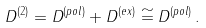<formula> <loc_0><loc_0><loc_500><loc_500>D ^ { ( 2 ) } & = D ^ { ( p o l ) } + D ^ { ( e x ) } \cong D ^ { ( p o l ) } \, .</formula> 